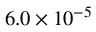Convert formula to latex. <formula><loc_0><loc_0><loc_500><loc_500>6 . 0 \times 1 0 ^ { - 5 }</formula> 